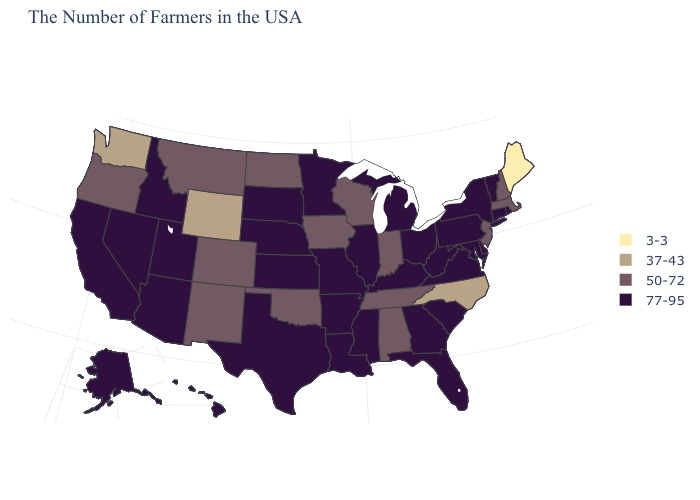Which states have the lowest value in the USA?
Write a very short answer. Maine. What is the value of Hawaii?
Keep it brief. 77-95. Name the states that have a value in the range 37-43?
Concise answer only. North Carolina, Wyoming, Washington. Name the states that have a value in the range 77-95?
Answer briefly. Rhode Island, Vermont, Connecticut, New York, Delaware, Maryland, Pennsylvania, Virginia, South Carolina, West Virginia, Ohio, Florida, Georgia, Michigan, Kentucky, Illinois, Mississippi, Louisiana, Missouri, Arkansas, Minnesota, Kansas, Nebraska, Texas, South Dakota, Utah, Arizona, Idaho, Nevada, California, Alaska, Hawaii. Is the legend a continuous bar?
Short answer required. No. What is the value of Louisiana?
Concise answer only. 77-95. Name the states that have a value in the range 37-43?
Be succinct. North Carolina, Wyoming, Washington. Does the first symbol in the legend represent the smallest category?
Concise answer only. Yes. What is the highest value in states that border Iowa?
Quick response, please. 77-95. Among the states that border Delaware , does New Jersey have the lowest value?
Give a very brief answer. Yes. Which states have the lowest value in the Northeast?
Write a very short answer. Maine. Name the states that have a value in the range 3-3?
Answer briefly. Maine. What is the value of Utah?
Concise answer only. 77-95. What is the value of Arkansas?
Give a very brief answer. 77-95. Name the states that have a value in the range 3-3?
Short answer required. Maine. 